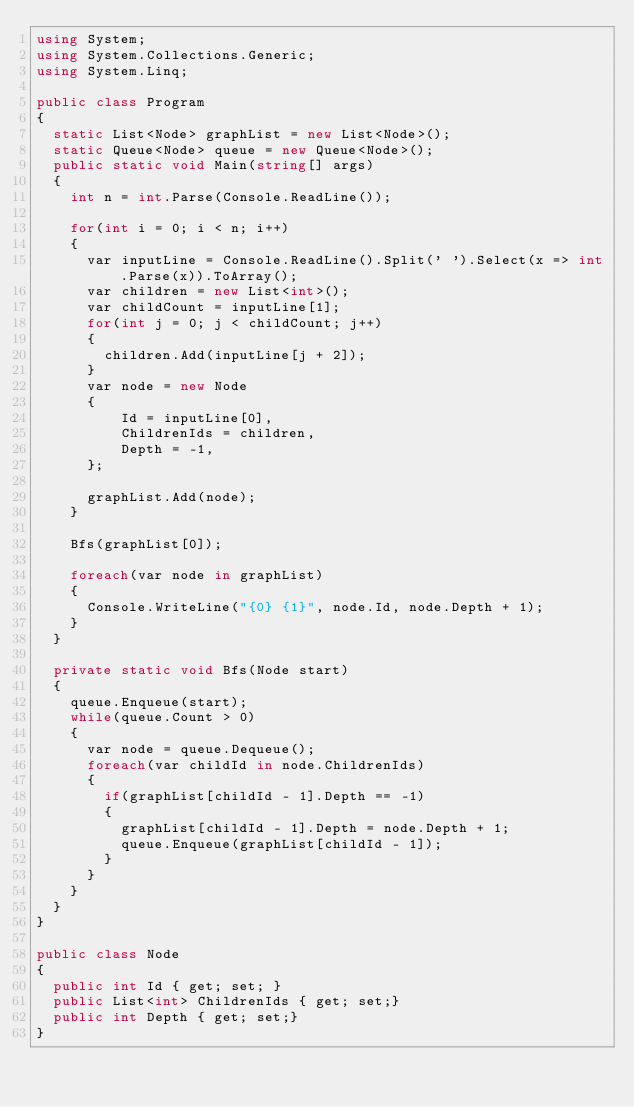Convert code to text. <code><loc_0><loc_0><loc_500><loc_500><_C#_>using System;
using System.Collections.Generic;
using System.Linq;

public class Program
{
  static List<Node> graphList = new List<Node>();
  static Queue<Node> queue = new Queue<Node>();
  public static void Main(string[] args)
  {
    int n = int.Parse(Console.ReadLine());

    for(int i = 0; i < n; i++)
    {
      var inputLine = Console.ReadLine().Split(' ').Select(x => int.Parse(x)).ToArray();
      var children = new List<int>();
      var childCount = inputLine[1];
      for(int j = 0; j < childCount; j++)
      {
        children.Add(inputLine[j + 2]);
      }
      var node = new Node
      {
          Id = inputLine[0],
          ChildrenIds = children,
          Depth = -1,
      };

      graphList.Add(node);
    }

    Bfs(graphList[0]);

    foreach(var node in graphList)
    {
      Console.WriteLine("{0} {1}", node.Id, node.Depth + 1);
    }
  }

  private static void Bfs(Node start)
  {
    queue.Enqueue(start);
    while(queue.Count > 0)
    {
      var node = queue.Dequeue();
      foreach(var childId in node.ChildrenIds)
      {
        if(graphList[childId - 1].Depth == -1)
        {
          graphList[childId - 1].Depth = node.Depth + 1;
          queue.Enqueue(graphList[childId - 1]);
        }
      }
    }
  }
}

public class Node
{
  public int Id { get; set; }
  public List<int> ChildrenIds { get; set;}
  public int Depth { get; set;}
}

</code> 